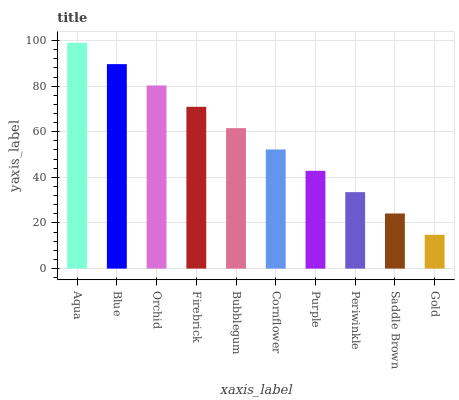Is Gold the minimum?
Answer yes or no. Yes. Is Aqua the maximum?
Answer yes or no. Yes. Is Blue the minimum?
Answer yes or no. No. Is Blue the maximum?
Answer yes or no. No. Is Aqua greater than Blue?
Answer yes or no. Yes. Is Blue less than Aqua?
Answer yes or no. Yes. Is Blue greater than Aqua?
Answer yes or no. No. Is Aqua less than Blue?
Answer yes or no. No. Is Bubblegum the high median?
Answer yes or no. Yes. Is Cornflower the low median?
Answer yes or no. Yes. Is Firebrick the high median?
Answer yes or no. No. Is Purple the low median?
Answer yes or no. No. 